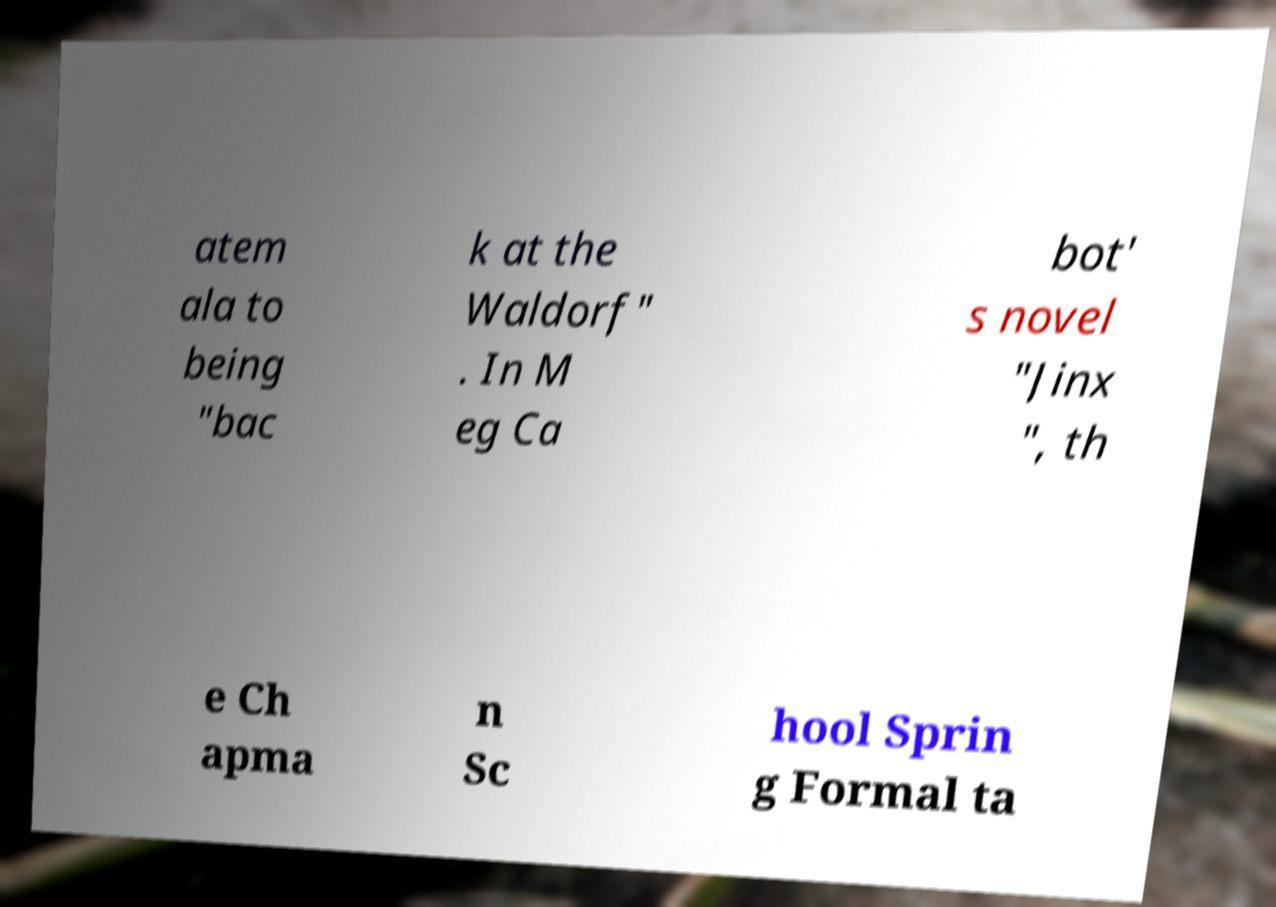Can you read and provide the text displayed in the image?This photo seems to have some interesting text. Can you extract and type it out for me? atem ala to being "bac k at the Waldorf" . In M eg Ca bot' s novel "Jinx ", th e Ch apma n Sc hool Sprin g Formal ta 